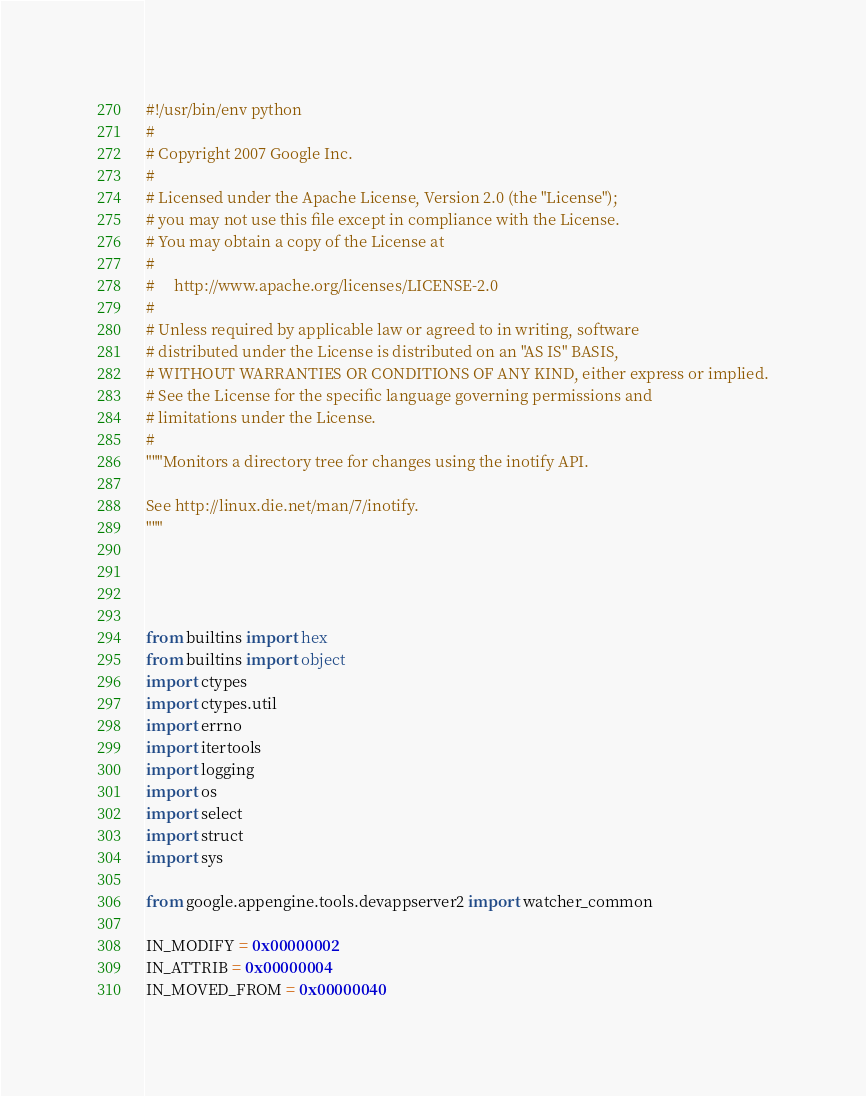Convert code to text. <code><loc_0><loc_0><loc_500><loc_500><_Python_>#!/usr/bin/env python
#
# Copyright 2007 Google Inc.
#
# Licensed under the Apache License, Version 2.0 (the "License");
# you may not use this file except in compliance with the License.
# You may obtain a copy of the License at
#
#     http://www.apache.org/licenses/LICENSE-2.0
#
# Unless required by applicable law or agreed to in writing, software
# distributed under the License is distributed on an "AS IS" BASIS,
# WITHOUT WARRANTIES OR CONDITIONS OF ANY KIND, either express or implied.
# See the License for the specific language governing permissions and
# limitations under the License.
#
"""Monitors a directory tree for changes using the inotify API.

See http://linux.die.net/man/7/inotify.
"""




from builtins import hex
from builtins import object
import ctypes
import ctypes.util
import errno
import itertools
import logging
import os
import select
import struct
import sys

from google.appengine.tools.devappserver2 import watcher_common

IN_MODIFY = 0x00000002
IN_ATTRIB = 0x00000004
IN_MOVED_FROM = 0x00000040</code> 